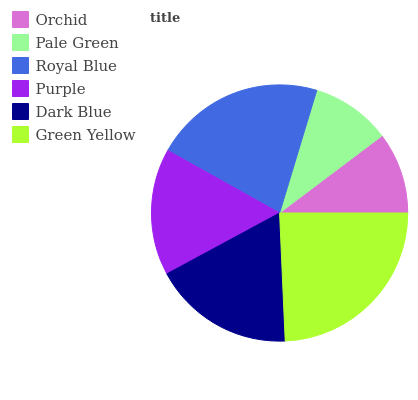Is Pale Green the minimum?
Answer yes or no. Yes. Is Green Yellow the maximum?
Answer yes or no. Yes. Is Royal Blue the minimum?
Answer yes or no. No. Is Royal Blue the maximum?
Answer yes or no. No. Is Royal Blue greater than Pale Green?
Answer yes or no. Yes. Is Pale Green less than Royal Blue?
Answer yes or no. Yes. Is Pale Green greater than Royal Blue?
Answer yes or no. No. Is Royal Blue less than Pale Green?
Answer yes or no. No. Is Dark Blue the high median?
Answer yes or no. Yes. Is Purple the low median?
Answer yes or no. Yes. Is Orchid the high median?
Answer yes or no. No. Is Green Yellow the low median?
Answer yes or no. No. 